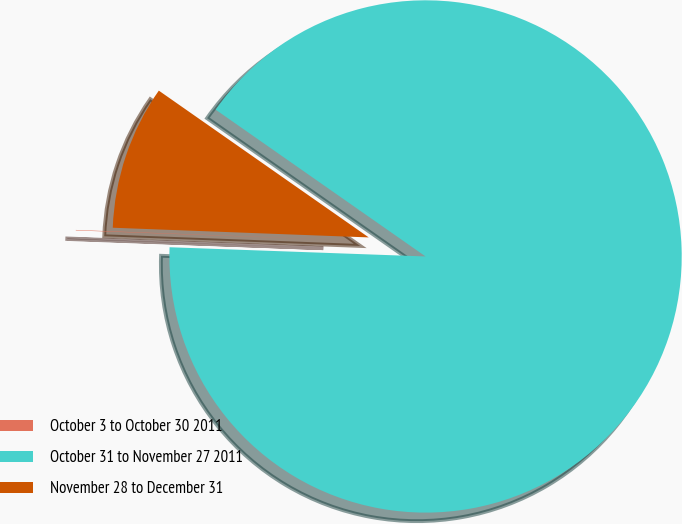<chart> <loc_0><loc_0><loc_500><loc_500><pie_chart><fcel>October 3 to October 30 2011<fcel>October 31 to November 27 2011<fcel>November 28 to December 31<nl><fcel>0.03%<fcel>90.86%<fcel>9.11%<nl></chart> 